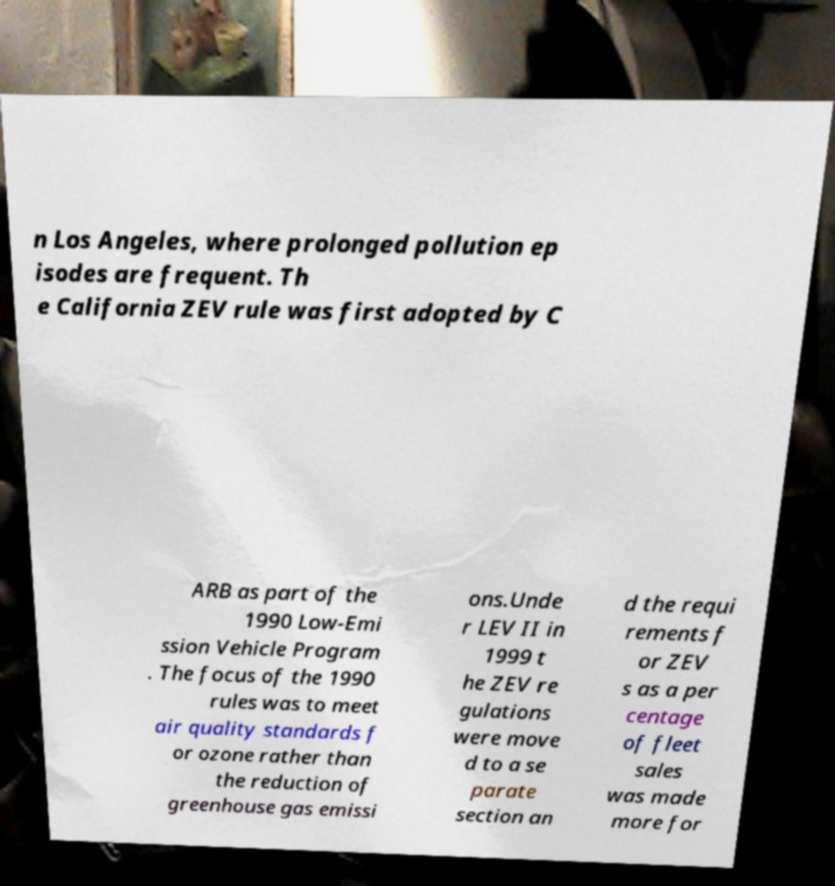Could you extract and type out the text from this image? n Los Angeles, where prolonged pollution ep isodes are frequent. Th e California ZEV rule was first adopted by C ARB as part of the 1990 Low-Emi ssion Vehicle Program . The focus of the 1990 rules was to meet air quality standards f or ozone rather than the reduction of greenhouse gas emissi ons.Unde r LEV II in 1999 t he ZEV re gulations were move d to a se parate section an d the requi rements f or ZEV s as a per centage of fleet sales was made more for 